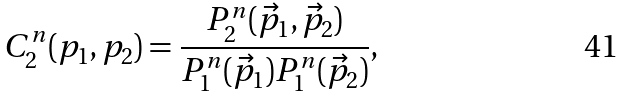Convert formula to latex. <formula><loc_0><loc_0><loc_500><loc_500>C _ { 2 } ^ { n } ( p _ { 1 } , p _ { 2 } ) = \frac { P _ { 2 } ^ { n } ( \vec { p } _ { 1 } , \vec { p } _ { 2 } ) } { P _ { 1 } ^ { n } ( \vec { p } _ { 1 } ) P _ { 1 } ^ { n } ( \vec { p } _ { 2 } ) } ,</formula> 